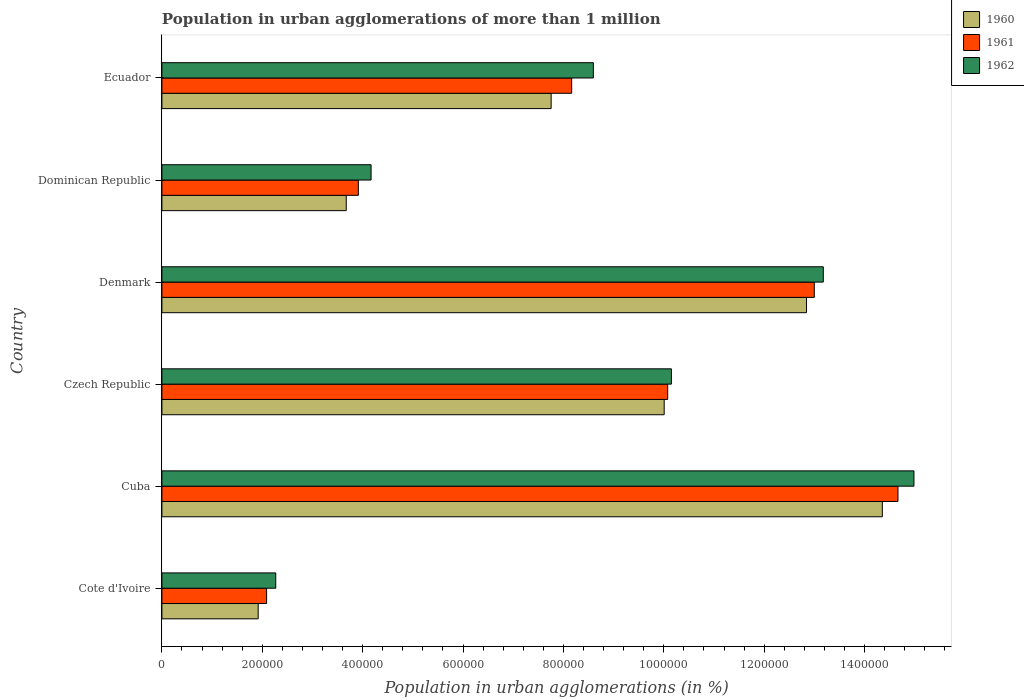How many different coloured bars are there?
Provide a short and direct response. 3. How many bars are there on the 4th tick from the top?
Your answer should be very brief. 3. How many bars are there on the 1st tick from the bottom?
Offer a very short reply. 3. What is the label of the 5th group of bars from the top?
Your answer should be compact. Cuba. In how many cases, is the number of bars for a given country not equal to the number of legend labels?
Provide a short and direct response. 0. What is the population in urban agglomerations in 1961 in Denmark?
Keep it short and to the point. 1.30e+06. Across all countries, what is the maximum population in urban agglomerations in 1961?
Provide a succinct answer. 1.47e+06. Across all countries, what is the minimum population in urban agglomerations in 1962?
Provide a succinct answer. 2.27e+05. In which country was the population in urban agglomerations in 1962 maximum?
Provide a short and direct response. Cuba. In which country was the population in urban agglomerations in 1961 minimum?
Offer a terse response. Cote d'Ivoire. What is the total population in urban agglomerations in 1962 in the graph?
Your answer should be very brief. 5.33e+06. What is the difference between the population in urban agglomerations in 1960 in Cuba and that in Denmark?
Make the answer very short. 1.51e+05. What is the difference between the population in urban agglomerations in 1961 in Denmark and the population in urban agglomerations in 1960 in Cuba?
Give a very brief answer. -1.36e+05. What is the average population in urban agglomerations in 1960 per country?
Ensure brevity in your answer.  8.43e+05. What is the difference between the population in urban agglomerations in 1962 and population in urban agglomerations in 1960 in Czech Republic?
Your response must be concise. 1.44e+04. In how many countries, is the population in urban agglomerations in 1961 greater than 440000 %?
Your response must be concise. 4. What is the ratio of the population in urban agglomerations in 1962 in Dominican Republic to that in Ecuador?
Give a very brief answer. 0.48. Is the population in urban agglomerations in 1960 in Denmark less than that in Ecuador?
Offer a terse response. No. Is the difference between the population in urban agglomerations in 1962 in Denmark and Dominican Republic greater than the difference between the population in urban agglomerations in 1960 in Denmark and Dominican Republic?
Your answer should be compact. No. What is the difference between the highest and the second highest population in urban agglomerations in 1960?
Give a very brief answer. 1.51e+05. What is the difference between the highest and the lowest population in urban agglomerations in 1961?
Your answer should be compact. 1.26e+06. Is the sum of the population in urban agglomerations in 1962 in Cuba and Czech Republic greater than the maximum population in urban agglomerations in 1960 across all countries?
Make the answer very short. Yes. What does the 3rd bar from the top in Dominican Republic represents?
Offer a very short reply. 1960. What does the 3rd bar from the bottom in Dominican Republic represents?
Provide a succinct answer. 1962. Is it the case that in every country, the sum of the population in urban agglomerations in 1962 and population in urban agglomerations in 1961 is greater than the population in urban agglomerations in 1960?
Provide a short and direct response. Yes. Are all the bars in the graph horizontal?
Your answer should be very brief. Yes. How many countries are there in the graph?
Make the answer very short. 6. What is the difference between two consecutive major ticks on the X-axis?
Ensure brevity in your answer.  2.00e+05. Are the values on the major ticks of X-axis written in scientific E-notation?
Give a very brief answer. No. Does the graph contain grids?
Your answer should be compact. No. Where does the legend appear in the graph?
Your answer should be compact. Top right. What is the title of the graph?
Make the answer very short. Population in urban agglomerations of more than 1 million. Does "2003" appear as one of the legend labels in the graph?
Your response must be concise. No. What is the label or title of the X-axis?
Provide a succinct answer. Population in urban agglomerations (in %). What is the label or title of the Y-axis?
Give a very brief answer. Country. What is the Population in urban agglomerations (in %) of 1960 in Cote d'Ivoire?
Offer a very short reply. 1.92e+05. What is the Population in urban agglomerations (in %) of 1961 in Cote d'Ivoire?
Provide a succinct answer. 2.09e+05. What is the Population in urban agglomerations (in %) in 1962 in Cote d'Ivoire?
Provide a short and direct response. 2.27e+05. What is the Population in urban agglomerations (in %) in 1960 in Cuba?
Ensure brevity in your answer.  1.44e+06. What is the Population in urban agglomerations (in %) in 1961 in Cuba?
Keep it short and to the point. 1.47e+06. What is the Population in urban agglomerations (in %) of 1962 in Cuba?
Ensure brevity in your answer.  1.50e+06. What is the Population in urban agglomerations (in %) of 1960 in Czech Republic?
Keep it short and to the point. 1.00e+06. What is the Population in urban agglomerations (in %) of 1961 in Czech Republic?
Offer a terse response. 1.01e+06. What is the Population in urban agglomerations (in %) in 1962 in Czech Republic?
Ensure brevity in your answer.  1.02e+06. What is the Population in urban agglomerations (in %) in 1960 in Denmark?
Offer a very short reply. 1.28e+06. What is the Population in urban agglomerations (in %) in 1961 in Denmark?
Offer a terse response. 1.30e+06. What is the Population in urban agglomerations (in %) of 1962 in Denmark?
Provide a short and direct response. 1.32e+06. What is the Population in urban agglomerations (in %) in 1960 in Dominican Republic?
Ensure brevity in your answer.  3.67e+05. What is the Population in urban agglomerations (in %) of 1961 in Dominican Republic?
Your answer should be very brief. 3.91e+05. What is the Population in urban agglomerations (in %) of 1962 in Dominican Republic?
Provide a succinct answer. 4.17e+05. What is the Population in urban agglomerations (in %) in 1960 in Ecuador?
Provide a short and direct response. 7.76e+05. What is the Population in urban agglomerations (in %) in 1961 in Ecuador?
Provide a succinct answer. 8.16e+05. What is the Population in urban agglomerations (in %) of 1962 in Ecuador?
Offer a terse response. 8.60e+05. Across all countries, what is the maximum Population in urban agglomerations (in %) in 1960?
Provide a succinct answer. 1.44e+06. Across all countries, what is the maximum Population in urban agglomerations (in %) of 1961?
Your response must be concise. 1.47e+06. Across all countries, what is the maximum Population in urban agglomerations (in %) in 1962?
Keep it short and to the point. 1.50e+06. Across all countries, what is the minimum Population in urban agglomerations (in %) of 1960?
Keep it short and to the point. 1.92e+05. Across all countries, what is the minimum Population in urban agglomerations (in %) of 1961?
Keep it short and to the point. 2.09e+05. Across all countries, what is the minimum Population in urban agglomerations (in %) in 1962?
Ensure brevity in your answer.  2.27e+05. What is the total Population in urban agglomerations (in %) in 1960 in the graph?
Provide a succinct answer. 5.06e+06. What is the total Population in urban agglomerations (in %) of 1961 in the graph?
Keep it short and to the point. 5.19e+06. What is the total Population in urban agglomerations (in %) of 1962 in the graph?
Give a very brief answer. 5.33e+06. What is the difference between the Population in urban agglomerations (in %) in 1960 in Cote d'Ivoire and that in Cuba?
Provide a succinct answer. -1.24e+06. What is the difference between the Population in urban agglomerations (in %) in 1961 in Cote d'Ivoire and that in Cuba?
Make the answer very short. -1.26e+06. What is the difference between the Population in urban agglomerations (in %) in 1962 in Cote d'Ivoire and that in Cuba?
Provide a short and direct response. -1.27e+06. What is the difference between the Population in urban agglomerations (in %) of 1960 in Cote d'Ivoire and that in Czech Republic?
Give a very brief answer. -8.09e+05. What is the difference between the Population in urban agglomerations (in %) of 1961 in Cote d'Ivoire and that in Czech Republic?
Offer a terse response. -7.99e+05. What is the difference between the Population in urban agglomerations (in %) in 1962 in Cote d'Ivoire and that in Czech Republic?
Offer a very short reply. -7.88e+05. What is the difference between the Population in urban agglomerations (in %) of 1960 in Cote d'Ivoire and that in Denmark?
Provide a short and direct response. -1.09e+06. What is the difference between the Population in urban agglomerations (in %) of 1961 in Cote d'Ivoire and that in Denmark?
Give a very brief answer. -1.09e+06. What is the difference between the Population in urban agglomerations (in %) in 1962 in Cote d'Ivoire and that in Denmark?
Offer a terse response. -1.09e+06. What is the difference between the Population in urban agglomerations (in %) of 1960 in Cote d'Ivoire and that in Dominican Republic?
Ensure brevity in your answer.  -1.75e+05. What is the difference between the Population in urban agglomerations (in %) in 1961 in Cote d'Ivoire and that in Dominican Republic?
Keep it short and to the point. -1.83e+05. What is the difference between the Population in urban agglomerations (in %) of 1962 in Cote d'Ivoire and that in Dominican Republic?
Give a very brief answer. -1.90e+05. What is the difference between the Population in urban agglomerations (in %) of 1960 in Cote d'Ivoire and that in Ecuador?
Provide a succinct answer. -5.84e+05. What is the difference between the Population in urban agglomerations (in %) of 1961 in Cote d'Ivoire and that in Ecuador?
Keep it short and to the point. -6.08e+05. What is the difference between the Population in urban agglomerations (in %) in 1962 in Cote d'Ivoire and that in Ecuador?
Ensure brevity in your answer.  -6.33e+05. What is the difference between the Population in urban agglomerations (in %) of 1960 in Cuba and that in Czech Republic?
Ensure brevity in your answer.  4.35e+05. What is the difference between the Population in urban agglomerations (in %) of 1961 in Cuba and that in Czech Republic?
Provide a succinct answer. 4.59e+05. What is the difference between the Population in urban agglomerations (in %) of 1962 in Cuba and that in Czech Republic?
Give a very brief answer. 4.83e+05. What is the difference between the Population in urban agglomerations (in %) in 1960 in Cuba and that in Denmark?
Keep it short and to the point. 1.51e+05. What is the difference between the Population in urban agglomerations (in %) of 1961 in Cuba and that in Denmark?
Offer a terse response. 1.67e+05. What is the difference between the Population in urban agglomerations (in %) in 1962 in Cuba and that in Denmark?
Provide a succinct answer. 1.81e+05. What is the difference between the Population in urban agglomerations (in %) of 1960 in Cuba and that in Dominican Republic?
Offer a terse response. 1.07e+06. What is the difference between the Population in urban agglomerations (in %) in 1961 in Cuba and that in Dominican Republic?
Provide a succinct answer. 1.08e+06. What is the difference between the Population in urban agglomerations (in %) of 1962 in Cuba and that in Dominican Republic?
Ensure brevity in your answer.  1.08e+06. What is the difference between the Population in urban agglomerations (in %) of 1960 in Cuba and that in Ecuador?
Provide a succinct answer. 6.60e+05. What is the difference between the Population in urban agglomerations (in %) of 1961 in Cuba and that in Ecuador?
Ensure brevity in your answer.  6.50e+05. What is the difference between the Population in urban agglomerations (in %) in 1962 in Cuba and that in Ecuador?
Offer a very short reply. 6.39e+05. What is the difference between the Population in urban agglomerations (in %) in 1960 in Czech Republic and that in Denmark?
Offer a very short reply. -2.84e+05. What is the difference between the Population in urban agglomerations (in %) in 1961 in Czech Republic and that in Denmark?
Your response must be concise. -2.92e+05. What is the difference between the Population in urban agglomerations (in %) of 1962 in Czech Republic and that in Denmark?
Your answer should be very brief. -3.03e+05. What is the difference between the Population in urban agglomerations (in %) in 1960 in Czech Republic and that in Dominican Republic?
Offer a terse response. 6.34e+05. What is the difference between the Population in urban agglomerations (in %) of 1961 in Czech Republic and that in Dominican Republic?
Make the answer very short. 6.16e+05. What is the difference between the Population in urban agglomerations (in %) of 1962 in Czech Republic and that in Dominican Republic?
Your answer should be very brief. 5.98e+05. What is the difference between the Population in urban agglomerations (in %) in 1960 in Czech Republic and that in Ecuador?
Keep it short and to the point. 2.25e+05. What is the difference between the Population in urban agglomerations (in %) in 1961 in Czech Republic and that in Ecuador?
Give a very brief answer. 1.91e+05. What is the difference between the Population in urban agglomerations (in %) of 1962 in Czech Republic and that in Ecuador?
Make the answer very short. 1.56e+05. What is the difference between the Population in urban agglomerations (in %) in 1960 in Denmark and that in Dominican Republic?
Keep it short and to the point. 9.17e+05. What is the difference between the Population in urban agglomerations (in %) of 1961 in Denmark and that in Dominican Republic?
Provide a short and direct response. 9.09e+05. What is the difference between the Population in urban agglomerations (in %) in 1962 in Denmark and that in Dominican Republic?
Make the answer very short. 9.01e+05. What is the difference between the Population in urban agglomerations (in %) of 1960 in Denmark and that in Ecuador?
Offer a terse response. 5.09e+05. What is the difference between the Population in urban agglomerations (in %) in 1961 in Denmark and that in Ecuador?
Offer a very short reply. 4.83e+05. What is the difference between the Population in urban agglomerations (in %) in 1962 in Denmark and that in Ecuador?
Ensure brevity in your answer.  4.58e+05. What is the difference between the Population in urban agglomerations (in %) in 1960 in Dominican Republic and that in Ecuador?
Ensure brevity in your answer.  -4.08e+05. What is the difference between the Population in urban agglomerations (in %) in 1961 in Dominican Republic and that in Ecuador?
Provide a succinct answer. -4.25e+05. What is the difference between the Population in urban agglomerations (in %) in 1962 in Dominican Republic and that in Ecuador?
Offer a terse response. -4.43e+05. What is the difference between the Population in urban agglomerations (in %) of 1960 in Cote d'Ivoire and the Population in urban agglomerations (in %) of 1961 in Cuba?
Ensure brevity in your answer.  -1.27e+06. What is the difference between the Population in urban agglomerations (in %) in 1960 in Cote d'Ivoire and the Population in urban agglomerations (in %) in 1962 in Cuba?
Give a very brief answer. -1.31e+06. What is the difference between the Population in urban agglomerations (in %) in 1961 in Cote d'Ivoire and the Population in urban agglomerations (in %) in 1962 in Cuba?
Make the answer very short. -1.29e+06. What is the difference between the Population in urban agglomerations (in %) in 1960 in Cote d'Ivoire and the Population in urban agglomerations (in %) in 1961 in Czech Republic?
Offer a very short reply. -8.16e+05. What is the difference between the Population in urban agglomerations (in %) of 1960 in Cote d'Ivoire and the Population in urban agglomerations (in %) of 1962 in Czech Republic?
Offer a terse response. -8.23e+05. What is the difference between the Population in urban agglomerations (in %) in 1961 in Cote d'Ivoire and the Population in urban agglomerations (in %) in 1962 in Czech Republic?
Ensure brevity in your answer.  -8.07e+05. What is the difference between the Population in urban agglomerations (in %) of 1960 in Cote d'Ivoire and the Population in urban agglomerations (in %) of 1961 in Denmark?
Give a very brief answer. -1.11e+06. What is the difference between the Population in urban agglomerations (in %) of 1960 in Cote d'Ivoire and the Population in urban agglomerations (in %) of 1962 in Denmark?
Give a very brief answer. -1.13e+06. What is the difference between the Population in urban agglomerations (in %) in 1961 in Cote d'Ivoire and the Population in urban agglomerations (in %) in 1962 in Denmark?
Ensure brevity in your answer.  -1.11e+06. What is the difference between the Population in urban agglomerations (in %) in 1960 in Cote d'Ivoire and the Population in urban agglomerations (in %) in 1961 in Dominican Republic?
Your answer should be very brief. -2.00e+05. What is the difference between the Population in urban agglomerations (in %) of 1960 in Cote d'Ivoire and the Population in urban agglomerations (in %) of 1962 in Dominican Republic?
Your answer should be compact. -2.25e+05. What is the difference between the Population in urban agglomerations (in %) in 1961 in Cote d'Ivoire and the Population in urban agglomerations (in %) in 1962 in Dominican Republic?
Offer a very short reply. -2.08e+05. What is the difference between the Population in urban agglomerations (in %) in 1960 in Cote d'Ivoire and the Population in urban agglomerations (in %) in 1961 in Ecuador?
Your answer should be very brief. -6.25e+05. What is the difference between the Population in urban agglomerations (in %) in 1960 in Cote d'Ivoire and the Population in urban agglomerations (in %) in 1962 in Ecuador?
Your response must be concise. -6.68e+05. What is the difference between the Population in urban agglomerations (in %) of 1961 in Cote d'Ivoire and the Population in urban agglomerations (in %) of 1962 in Ecuador?
Ensure brevity in your answer.  -6.51e+05. What is the difference between the Population in urban agglomerations (in %) of 1960 in Cuba and the Population in urban agglomerations (in %) of 1961 in Czech Republic?
Make the answer very short. 4.28e+05. What is the difference between the Population in urban agglomerations (in %) in 1960 in Cuba and the Population in urban agglomerations (in %) in 1962 in Czech Republic?
Ensure brevity in your answer.  4.20e+05. What is the difference between the Population in urban agglomerations (in %) of 1961 in Cuba and the Population in urban agglomerations (in %) of 1962 in Czech Republic?
Ensure brevity in your answer.  4.51e+05. What is the difference between the Population in urban agglomerations (in %) in 1960 in Cuba and the Population in urban agglomerations (in %) in 1961 in Denmark?
Keep it short and to the point. 1.36e+05. What is the difference between the Population in urban agglomerations (in %) in 1960 in Cuba and the Population in urban agglomerations (in %) in 1962 in Denmark?
Make the answer very short. 1.18e+05. What is the difference between the Population in urban agglomerations (in %) in 1961 in Cuba and the Population in urban agglomerations (in %) in 1962 in Denmark?
Provide a short and direct response. 1.49e+05. What is the difference between the Population in urban agglomerations (in %) in 1960 in Cuba and the Population in urban agglomerations (in %) in 1961 in Dominican Republic?
Keep it short and to the point. 1.04e+06. What is the difference between the Population in urban agglomerations (in %) in 1960 in Cuba and the Population in urban agglomerations (in %) in 1962 in Dominican Republic?
Provide a succinct answer. 1.02e+06. What is the difference between the Population in urban agglomerations (in %) in 1961 in Cuba and the Population in urban agglomerations (in %) in 1962 in Dominican Republic?
Provide a short and direct response. 1.05e+06. What is the difference between the Population in urban agglomerations (in %) in 1960 in Cuba and the Population in urban agglomerations (in %) in 1961 in Ecuador?
Ensure brevity in your answer.  6.19e+05. What is the difference between the Population in urban agglomerations (in %) of 1960 in Cuba and the Population in urban agglomerations (in %) of 1962 in Ecuador?
Your response must be concise. 5.76e+05. What is the difference between the Population in urban agglomerations (in %) in 1961 in Cuba and the Population in urban agglomerations (in %) in 1962 in Ecuador?
Your response must be concise. 6.07e+05. What is the difference between the Population in urban agglomerations (in %) of 1960 in Czech Republic and the Population in urban agglomerations (in %) of 1961 in Denmark?
Offer a very short reply. -2.99e+05. What is the difference between the Population in urban agglomerations (in %) in 1960 in Czech Republic and the Population in urban agglomerations (in %) in 1962 in Denmark?
Provide a short and direct response. -3.17e+05. What is the difference between the Population in urban agglomerations (in %) in 1961 in Czech Republic and the Population in urban agglomerations (in %) in 1962 in Denmark?
Offer a very short reply. -3.10e+05. What is the difference between the Population in urban agglomerations (in %) in 1960 in Czech Republic and the Population in urban agglomerations (in %) in 1961 in Dominican Republic?
Provide a succinct answer. 6.09e+05. What is the difference between the Population in urban agglomerations (in %) of 1960 in Czech Republic and the Population in urban agglomerations (in %) of 1962 in Dominican Republic?
Give a very brief answer. 5.84e+05. What is the difference between the Population in urban agglomerations (in %) of 1961 in Czech Republic and the Population in urban agglomerations (in %) of 1962 in Dominican Republic?
Ensure brevity in your answer.  5.91e+05. What is the difference between the Population in urban agglomerations (in %) in 1960 in Czech Republic and the Population in urban agglomerations (in %) in 1961 in Ecuador?
Provide a succinct answer. 1.84e+05. What is the difference between the Population in urban agglomerations (in %) in 1960 in Czech Republic and the Population in urban agglomerations (in %) in 1962 in Ecuador?
Offer a very short reply. 1.41e+05. What is the difference between the Population in urban agglomerations (in %) in 1961 in Czech Republic and the Population in urban agglomerations (in %) in 1962 in Ecuador?
Your answer should be compact. 1.48e+05. What is the difference between the Population in urban agglomerations (in %) of 1960 in Denmark and the Population in urban agglomerations (in %) of 1961 in Dominican Republic?
Provide a short and direct response. 8.93e+05. What is the difference between the Population in urban agglomerations (in %) of 1960 in Denmark and the Population in urban agglomerations (in %) of 1962 in Dominican Republic?
Give a very brief answer. 8.68e+05. What is the difference between the Population in urban agglomerations (in %) of 1961 in Denmark and the Population in urban agglomerations (in %) of 1962 in Dominican Republic?
Make the answer very short. 8.83e+05. What is the difference between the Population in urban agglomerations (in %) of 1960 in Denmark and the Population in urban agglomerations (in %) of 1961 in Ecuador?
Provide a succinct answer. 4.68e+05. What is the difference between the Population in urban agglomerations (in %) of 1960 in Denmark and the Population in urban agglomerations (in %) of 1962 in Ecuador?
Your answer should be very brief. 4.25e+05. What is the difference between the Population in urban agglomerations (in %) of 1961 in Denmark and the Population in urban agglomerations (in %) of 1962 in Ecuador?
Your answer should be very brief. 4.40e+05. What is the difference between the Population in urban agglomerations (in %) of 1960 in Dominican Republic and the Population in urban agglomerations (in %) of 1961 in Ecuador?
Make the answer very short. -4.49e+05. What is the difference between the Population in urban agglomerations (in %) in 1960 in Dominican Republic and the Population in urban agglomerations (in %) in 1962 in Ecuador?
Ensure brevity in your answer.  -4.92e+05. What is the difference between the Population in urban agglomerations (in %) in 1961 in Dominican Republic and the Population in urban agglomerations (in %) in 1962 in Ecuador?
Ensure brevity in your answer.  -4.68e+05. What is the average Population in urban agglomerations (in %) in 1960 per country?
Your answer should be compact. 8.43e+05. What is the average Population in urban agglomerations (in %) of 1961 per country?
Offer a terse response. 8.65e+05. What is the average Population in urban agglomerations (in %) of 1962 per country?
Keep it short and to the point. 8.89e+05. What is the difference between the Population in urban agglomerations (in %) of 1960 and Population in urban agglomerations (in %) of 1961 in Cote d'Ivoire?
Offer a very short reply. -1.68e+04. What is the difference between the Population in urban agglomerations (in %) of 1960 and Population in urban agglomerations (in %) of 1962 in Cote d'Ivoire?
Provide a short and direct response. -3.50e+04. What is the difference between the Population in urban agglomerations (in %) of 1961 and Population in urban agglomerations (in %) of 1962 in Cote d'Ivoire?
Give a very brief answer. -1.82e+04. What is the difference between the Population in urban agglomerations (in %) in 1960 and Population in urban agglomerations (in %) in 1961 in Cuba?
Your answer should be compact. -3.11e+04. What is the difference between the Population in urban agglomerations (in %) of 1960 and Population in urban agglomerations (in %) of 1962 in Cuba?
Your answer should be compact. -6.30e+04. What is the difference between the Population in urban agglomerations (in %) of 1961 and Population in urban agglomerations (in %) of 1962 in Cuba?
Offer a very short reply. -3.18e+04. What is the difference between the Population in urban agglomerations (in %) of 1960 and Population in urban agglomerations (in %) of 1961 in Czech Republic?
Offer a very short reply. -7004. What is the difference between the Population in urban agglomerations (in %) of 1960 and Population in urban agglomerations (in %) of 1962 in Czech Republic?
Make the answer very short. -1.44e+04. What is the difference between the Population in urban agglomerations (in %) in 1961 and Population in urban agglomerations (in %) in 1962 in Czech Republic?
Provide a succinct answer. -7379. What is the difference between the Population in urban agglomerations (in %) of 1960 and Population in urban agglomerations (in %) of 1961 in Denmark?
Offer a very short reply. -1.55e+04. What is the difference between the Population in urban agglomerations (in %) in 1960 and Population in urban agglomerations (in %) in 1962 in Denmark?
Give a very brief answer. -3.34e+04. What is the difference between the Population in urban agglomerations (in %) in 1961 and Population in urban agglomerations (in %) in 1962 in Denmark?
Your answer should be very brief. -1.79e+04. What is the difference between the Population in urban agglomerations (in %) of 1960 and Population in urban agglomerations (in %) of 1961 in Dominican Republic?
Give a very brief answer. -2.41e+04. What is the difference between the Population in urban agglomerations (in %) of 1960 and Population in urban agglomerations (in %) of 1962 in Dominican Republic?
Offer a terse response. -4.95e+04. What is the difference between the Population in urban agglomerations (in %) of 1961 and Population in urban agglomerations (in %) of 1962 in Dominican Republic?
Offer a very short reply. -2.54e+04. What is the difference between the Population in urban agglomerations (in %) of 1960 and Population in urban agglomerations (in %) of 1961 in Ecuador?
Provide a short and direct response. -4.09e+04. What is the difference between the Population in urban agglomerations (in %) of 1960 and Population in urban agglomerations (in %) of 1962 in Ecuador?
Your answer should be very brief. -8.41e+04. What is the difference between the Population in urban agglomerations (in %) in 1961 and Population in urban agglomerations (in %) in 1962 in Ecuador?
Offer a very short reply. -4.32e+04. What is the ratio of the Population in urban agglomerations (in %) in 1960 in Cote d'Ivoire to that in Cuba?
Offer a terse response. 0.13. What is the ratio of the Population in urban agglomerations (in %) of 1961 in Cote d'Ivoire to that in Cuba?
Offer a very short reply. 0.14. What is the ratio of the Population in urban agglomerations (in %) in 1962 in Cote d'Ivoire to that in Cuba?
Offer a terse response. 0.15. What is the ratio of the Population in urban agglomerations (in %) in 1960 in Cote d'Ivoire to that in Czech Republic?
Your answer should be very brief. 0.19. What is the ratio of the Population in urban agglomerations (in %) in 1961 in Cote d'Ivoire to that in Czech Republic?
Make the answer very short. 0.21. What is the ratio of the Population in urban agglomerations (in %) of 1962 in Cote d'Ivoire to that in Czech Republic?
Make the answer very short. 0.22. What is the ratio of the Population in urban agglomerations (in %) in 1960 in Cote d'Ivoire to that in Denmark?
Offer a terse response. 0.15. What is the ratio of the Population in urban agglomerations (in %) in 1961 in Cote d'Ivoire to that in Denmark?
Your response must be concise. 0.16. What is the ratio of the Population in urban agglomerations (in %) of 1962 in Cote d'Ivoire to that in Denmark?
Give a very brief answer. 0.17. What is the ratio of the Population in urban agglomerations (in %) of 1960 in Cote d'Ivoire to that in Dominican Republic?
Your answer should be very brief. 0.52. What is the ratio of the Population in urban agglomerations (in %) in 1961 in Cote d'Ivoire to that in Dominican Republic?
Provide a succinct answer. 0.53. What is the ratio of the Population in urban agglomerations (in %) in 1962 in Cote d'Ivoire to that in Dominican Republic?
Your answer should be compact. 0.54. What is the ratio of the Population in urban agglomerations (in %) in 1960 in Cote d'Ivoire to that in Ecuador?
Your response must be concise. 0.25. What is the ratio of the Population in urban agglomerations (in %) of 1961 in Cote d'Ivoire to that in Ecuador?
Make the answer very short. 0.26. What is the ratio of the Population in urban agglomerations (in %) of 1962 in Cote d'Ivoire to that in Ecuador?
Offer a very short reply. 0.26. What is the ratio of the Population in urban agglomerations (in %) of 1960 in Cuba to that in Czech Republic?
Provide a short and direct response. 1.43. What is the ratio of the Population in urban agglomerations (in %) of 1961 in Cuba to that in Czech Republic?
Make the answer very short. 1.46. What is the ratio of the Population in urban agglomerations (in %) of 1962 in Cuba to that in Czech Republic?
Offer a terse response. 1.48. What is the ratio of the Population in urban agglomerations (in %) in 1960 in Cuba to that in Denmark?
Provide a short and direct response. 1.12. What is the ratio of the Population in urban agglomerations (in %) in 1961 in Cuba to that in Denmark?
Keep it short and to the point. 1.13. What is the ratio of the Population in urban agglomerations (in %) in 1962 in Cuba to that in Denmark?
Offer a very short reply. 1.14. What is the ratio of the Population in urban agglomerations (in %) in 1960 in Cuba to that in Dominican Republic?
Your response must be concise. 3.91. What is the ratio of the Population in urban agglomerations (in %) in 1961 in Cuba to that in Dominican Republic?
Your response must be concise. 3.75. What is the ratio of the Population in urban agglomerations (in %) of 1962 in Cuba to that in Dominican Republic?
Provide a succinct answer. 3.6. What is the ratio of the Population in urban agglomerations (in %) of 1960 in Cuba to that in Ecuador?
Give a very brief answer. 1.85. What is the ratio of the Population in urban agglomerations (in %) in 1961 in Cuba to that in Ecuador?
Make the answer very short. 1.8. What is the ratio of the Population in urban agglomerations (in %) of 1962 in Cuba to that in Ecuador?
Provide a succinct answer. 1.74. What is the ratio of the Population in urban agglomerations (in %) in 1960 in Czech Republic to that in Denmark?
Provide a succinct answer. 0.78. What is the ratio of the Population in urban agglomerations (in %) in 1961 in Czech Republic to that in Denmark?
Ensure brevity in your answer.  0.78. What is the ratio of the Population in urban agglomerations (in %) in 1962 in Czech Republic to that in Denmark?
Your answer should be very brief. 0.77. What is the ratio of the Population in urban agglomerations (in %) of 1960 in Czech Republic to that in Dominican Republic?
Your answer should be compact. 2.72. What is the ratio of the Population in urban agglomerations (in %) of 1961 in Czech Republic to that in Dominican Republic?
Keep it short and to the point. 2.57. What is the ratio of the Population in urban agglomerations (in %) in 1962 in Czech Republic to that in Dominican Republic?
Provide a succinct answer. 2.44. What is the ratio of the Population in urban agglomerations (in %) of 1960 in Czech Republic to that in Ecuador?
Your answer should be very brief. 1.29. What is the ratio of the Population in urban agglomerations (in %) of 1961 in Czech Republic to that in Ecuador?
Offer a very short reply. 1.23. What is the ratio of the Population in urban agglomerations (in %) of 1962 in Czech Republic to that in Ecuador?
Provide a succinct answer. 1.18. What is the ratio of the Population in urban agglomerations (in %) of 1960 in Denmark to that in Dominican Republic?
Offer a terse response. 3.5. What is the ratio of the Population in urban agglomerations (in %) of 1961 in Denmark to that in Dominican Republic?
Provide a short and direct response. 3.32. What is the ratio of the Population in urban agglomerations (in %) in 1962 in Denmark to that in Dominican Republic?
Offer a very short reply. 3.16. What is the ratio of the Population in urban agglomerations (in %) of 1960 in Denmark to that in Ecuador?
Your answer should be very brief. 1.66. What is the ratio of the Population in urban agglomerations (in %) in 1961 in Denmark to that in Ecuador?
Ensure brevity in your answer.  1.59. What is the ratio of the Population in urban agglomerations (in %) in 1962 in Denmark to that in Ecuador?
Make the answer very short. 1.53. What is the ratio of the Population in urban agglomerations (in %) in 1960 in Dominican Republic to that in Ecuador?
Ensure brevity in your answer.  0.47. What is the ratio of the Population in urban agglomerations (in %) of 1961 in Dominican Republic to that in Ecuador?
Ensure brevity in your answer.  0.48. What is the ratio of the Population in urban agglomerations (in %) in 1962 in Dominican Republic to that in Ecuador?
Offer a terse response. 0.48. What is the difference between the highest and the second highest Population in urban agglomerations (in %) of 1960?
Make the answer very short. 1.51e+05. What is the difference between the highest and the second highest Population in urban agglomerations (in %) of 1961?
Provide a succinct answer. 1.67e+05. What is the difference between the highest and the second highest Population in urban agglomerations (in %) in 1962?
Make the answer very short. 1.81e+05. What is the difference between the highest and the lowest Population in urban agglomerations (in %) in 1960?
Your answer should be compact. 1.24e+06. What is the difference between the highest and the lowest Population in urban agglomerations (in %) of 1961?
Give a very brief answer. 1.26e+06. What is the difference between the highest and the lowest Population in urban agglomerations (in %) of 1962?
Ensure brevity in your answer.  1.27e+06. 